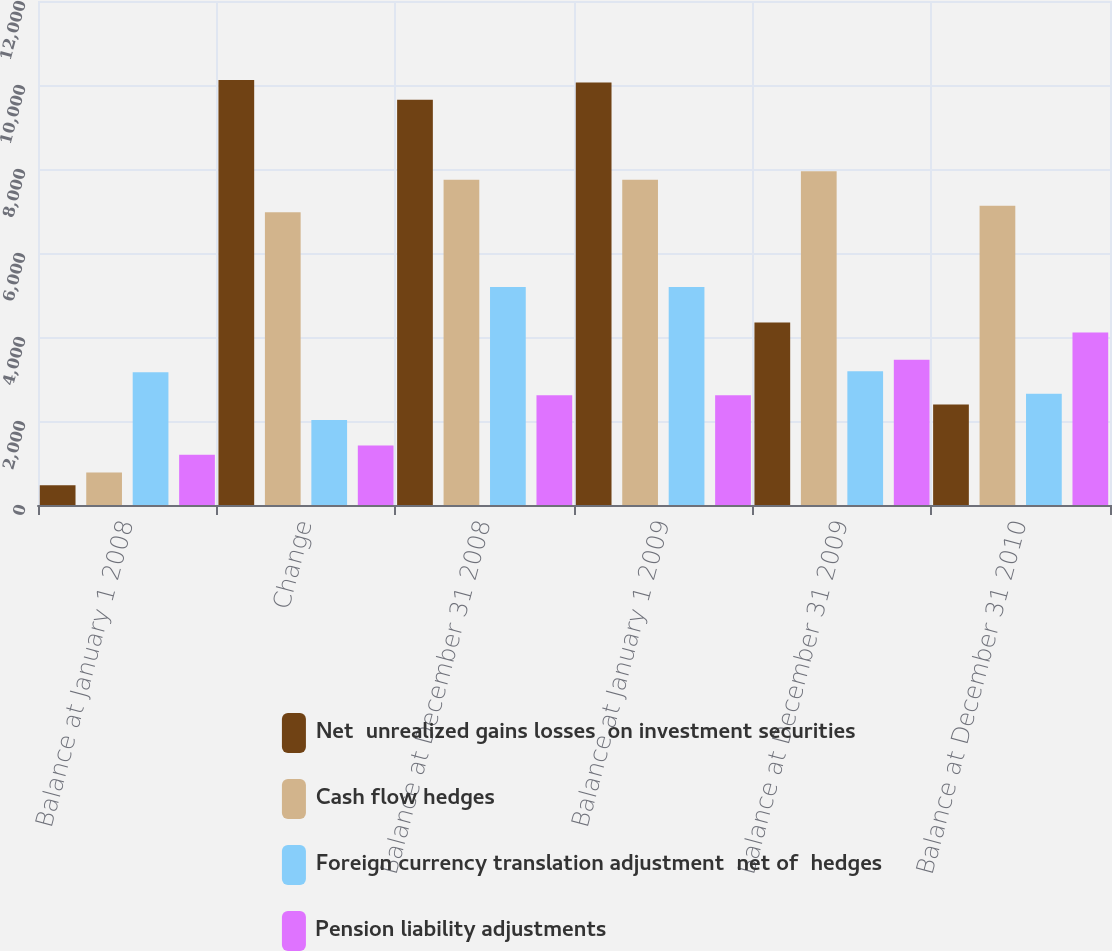Convert chart. <chart><loc_0><loc_0><loc_500><loc_500><stacked_bar_chart><ecel><fcel>Balance at January 1 2008<fcel>Change<fcel>Balance at December 31 2008<fcel>Balance at January 1 2009<fcel>Balance at December 31 2009<fcel>Balance at December 31 2010<nl><fcel>Net  unrealized gains losses  on investment securities<fcel>471<fcel>10118<fcel>9647<fcel>10060<fcel>4347<fcel>2395<nl><fcel>Cash flow hedges<fcel>772<fcel>6972<fcel>7744<fcel>7744<fcel>7947<fcel>7127<nl><fcel>Foreign currency translation adjustment  net of  hedges<fcel>3163<fcel>2026<fcel>5189<fcel>5189<fcel>3182<fcel>2650<nl><fcel>Pension liability adjustments<fcel>1196<fcel>1419<fcel>2615<fcel>2615<fcel>3461<fcel>4105<nl></chart> 